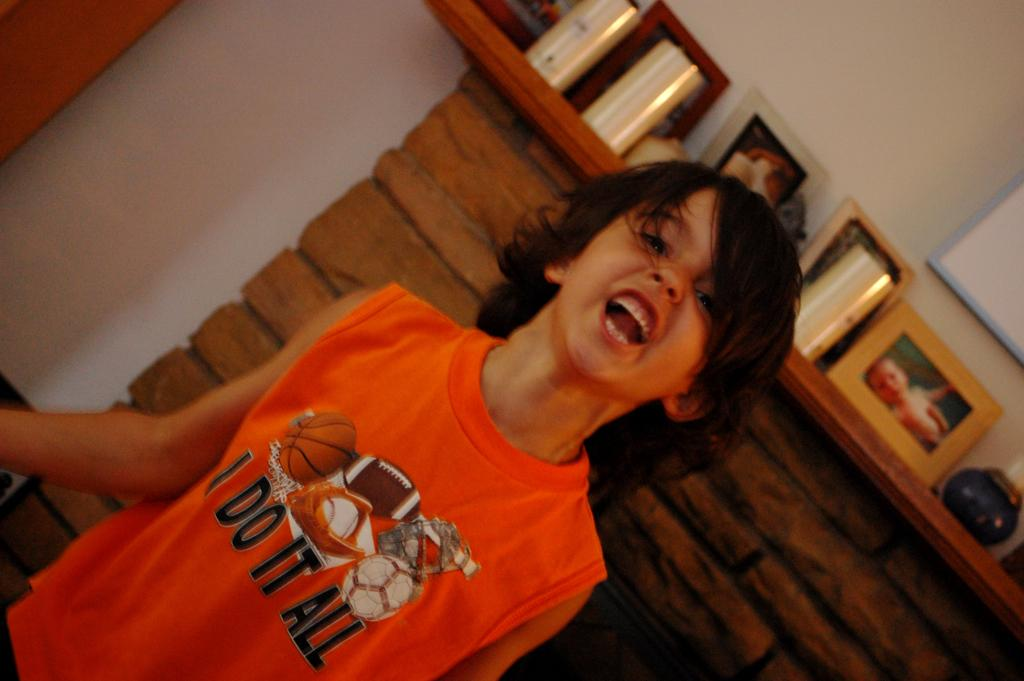<image>
Create a compact narrative representing the image presented. A child with a shirt with many different sport equipment that says 'I do it all.' 